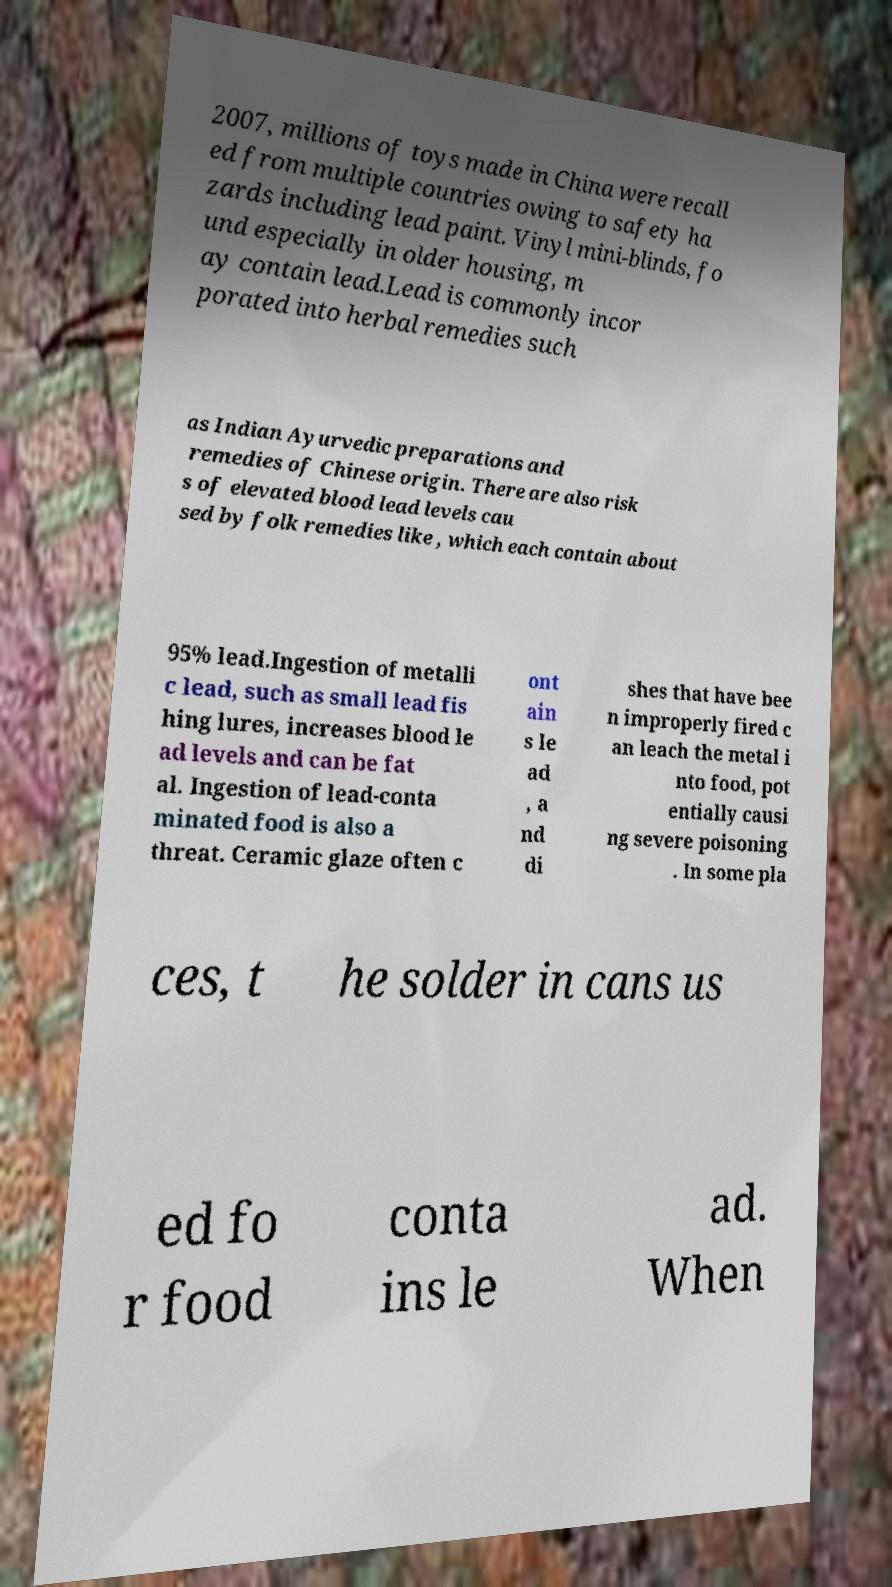There's text embedded in this image that I need extracted. Can you transcribe it verbatim? 2007, millions of toys made in China were recall ed from multiple countries owing to safety ha zards including lead paint. Vinyl mini-blinds, fo und especially in older housing, m ay contain lead.Lead is commonly incor porated into herbal remedies such as Indian Ayurvedic preparations and remedies of Chinese origin. There are also risk s of elevated blood lead levels cau sed by folk remedies like , which each contain about 95% lead.Ingestion of metalli c lead, such as small lead fis hing lures, increases blood le ad levels and can be fat al. Ingestion of lead-conta minated food is also a threat. Ceramic glaze often c ont ain s le ad , a nd di shes that have bee n improperly fired c an leach the metal i nto food, pot entially causi ng severe poisoning . In some pla ces, t he solder in cans us ed fo r food conta ins le ad. When 